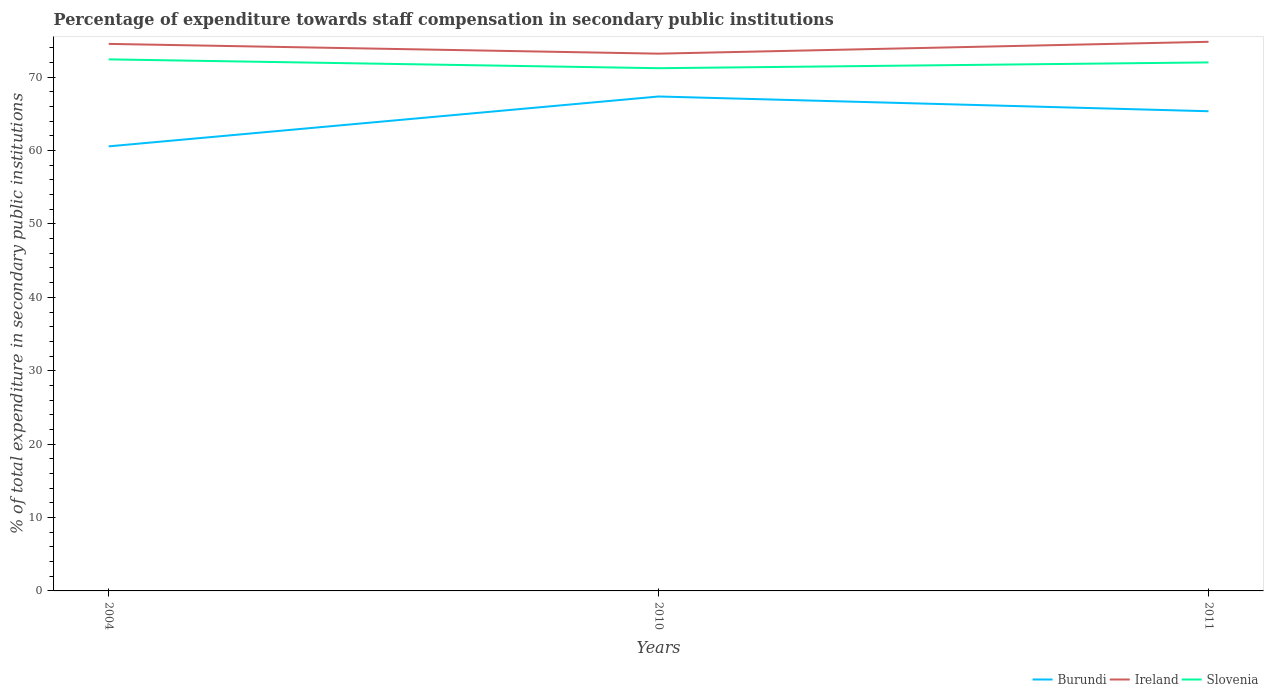Across all years, what is the maximum percentage of expenditure towards staff compensation in Burundi?
Ensure brevity in your answer.  60.57. In which year was the percentage of expenditure towards staff compensation in Burundi maximum?
Make the answer very short. 2004. What is the total percentage of expenditure towards staff compensation in Ireland in the graph?
Offer a terse response. -0.29. What is the difference between the highest and the second highest percentage of expenditure towards staff compensation in Slovenia?
Give a very brief answer. 1.2. How many lines are there?
Offer a very short reply. 3. How many years are there in the graph?
Offer a very short reply. 3. What is the difference between two consecutive major ticks on the Y-axis?
Give a very brief answer. 10. Are the values on the major ticks of Y-axis written in scientific E-notation?
Keep it short and to the point. No. Does the graph contain any zero values?
Ensure brevity in your answer.  No. Does the graph contain grids?
Ensure brevity in your answer.  No. How many legend labels are there?
Your answer should be very brief. 3. What is the title of the graph?
Make the answer very short. Percentage of expenditure towards staff compensation in secondary public institutions. Does "High income: OECD" appear as one of the legend labels in the graph?
Your response must be concise. No. What is the label or title of the Y-axis?
Give a very brief answer. % of total expenditure in secondary public institutions. What is the % of total expenditure in secondary public institutions of Burundi in 2004?
Your answer should be compact. 60.57. What is the % of total expenditure in secondary public institutions of Ireland in 2004?
Offer a terse response. 74.53. What is the % of total expenditure in secondary public institutions in Slovenia in 2004?
Ensure brevity in your answer.  72.42. What is the % of total expenditure in secondary public institutions in Burundi in 2010?
Your answer should be compact. 67.37. What is the % of total expenditure in secondary public institutions in Ireland in 2010?
Make the answer very short. 73.2. What is the % of total expenditure in secondary public institutions in Slovenia in 2010?
Offer a terse response. 71.22. What is the % of total expenditure in secondary public institutions of Burundi in 2011?
Offer a very short reply. 65.36. What is the % of total expenditure in secondary public institutions of Ireland in 2011?
Your response must be concise. 74.82. What is the % of total expenditure in secondary public institutions of Slovenia in 2011?
Give a very brief answer. 72.01. Across all years, what is the maximum % of total expenditure in secondary public institutions of Burundi?
Your answer should be very brief. 67.37. Across all years, what is the maximum % of total expenditure in secondary public institutions of Ireland?
Ensure brevity in your answer.  74.82. Across all years, what is the maximum % of total expenditure in secondary public institutions in Slovenia?
Your answer should be compact. 72.42. Across all years, what is the minimum % of total expenditure in secondary public institutions of Burundi?
Make the answer very short. 60.57. Across all years, what is the minimum % of total expenditure in secondary public institutions of Ireland?
Offer a very short reply. 73.2. Across all years, what is the minimum % of total expenditure in secondary public institutions in Slovenia?
Give a very brief answer. 71.22. What is the total % of total expenditure in secondary public institutions of Burundi in the graph?
Ensure brevity in your answer.  193.3. What is the total % of total expenditure in secondary public institutions of Ireland in the graph?
Provide a succinct answer. 222.55. What is the total % of total expenditure in secondary public institutions of Slovenia in the graph?
Your answer should be compact. 215.65. What is the difference between the % of total expenditure in secondary public institutions of Burundi in 2004 and that in 2010?
Make the answer very short. -6.79. What is the difference between the % of total expenditure in secondary public institutions in Ireland in 2004 and that in 2010?
Give a very brief answer. 1.33. What is the difference between the % of total expenditure in secondary public institutions in Slovenia in 2004 and that in 2010?
Your response must be concise. 1.2. What is the difference between the % of total expenditure in secondary public institutions of Burundi in 2004 and that in 2011?
Your response must be concise. -4.78. What is the difference between the % of total expenditure in secondary public institutions in Ireland in 2004 and that in 2011?
Keep it short and to the point. -0.29. What is the difference between the % of total expenditure in secondary public institutions in Slovenia in 2004 and that in 2011?
Keep it short and to the point. 0.42. What is the difference between the % of total expenditure in secondary public institutions in Burundi in 2010 and that in 2011?
Make the answer very short. 2.01. What is the difference between the % of total expenditure in secondary public institutions of Ireland in 2010 and that in 2011?
Keep it short and to the point. -1.62. What is the difference between the % of total expenditure in secondary public institutions in Slovenia in 2010 and that in 2011?
Provide a short and direct response. -0.79. What is the difference between the % of total expenditure in secondary public institutions in Burundi in 2004 and the % of total expenditure in secondary public institutions in Ireland in 2010?
Offer a very short reply. -12.63. What is the difference between the % of total expenditure in secondary public institutions of Burundi in 2004 and the % of total expenditure in secondary public institutions of Slovenia in 2010?
Make the answer very short. -10.65. What is the difference between the % of total expenditure in secondary public institutions in Ireland in 2004 and the % of total expenditure in secondary public institutions in Slovenia in 2010?
Provide a succinct answer. 3.31. What is the difference between the % of total expenditure in secondary public institutions in Burundi in 2004 and the % of total expenditure in secondary public institutions in Ireland in 2011?
Offer a terse response. -14.24. What is the difference between the % of total expenditure in secondary public institutions in Burundi in 2004 and the % of total expenditure in secondary public institutions in Slovenia in 2011?
Offer a very short reply. -11.44. What is the difference between the % of total expenditure in secondary public institutions of Ireland in 2004 and the % of total expenditure in secondary public institutions of Slovenia in 2011?
Your answer should be very brief. 2.52. What is the difference between the % of total expenditure in secondary public institutions in Burundi in 2010 and the % of total expenditure in secondary public institutions in Ireland in 2011?
Your answer should be compact. -7.45. What is the difference between the % of total expenditure in secondary public institutions of Burundi in 2010 and the % of total expenditure in secondary public institutions of Slovenia in 2011?
Offer a very short reply. -4.64. What is the difference between the % of total expenditure in secondary public institutions in Ireland in 2010 and the % of total expenditure in secondary public institutions in Slovenia in 2011?
Provide a short and direct response. 1.19. What is the average % of total expenditure in secondary public institutions in Burundi per year?
Provide a short and direct response. 64.43. What is the average % of total expenditure in secondary public institutions of Ireland per year?
Give a very brief answer. 74.18. What is the average % of total expenditure in secondary public institutions in Slovenia per year?
Offer a very short reply. 71.88. In the year 2004, what is the difference between the % of total expenditure in secondary public institutions in Burundi and % of total expenditure in secondary public institutions in Ireland?
Offer a terse response. -13.96. In the year 2004, what is the difference between the % of total expenditure in secondary public institutions in Burundi and % of total expenditure in secondary public institutions in Slovenia?
Provide a succinct answer. -11.85. In the year 2004, what is the difference between the % of total expenditure in secondary public institutions of Ireland and % of total expenditure in secondary public institutions of Slovenia?
Give a very brief answer. 2.11. In the year 2010, what is the difference between the % of total expenditure in secondary public institutions of Burundi and % of total expenditure in secondary public institutions of Ireland?
Your answer should be compact. -5.84. In the year 2010, what is the difference between the % of total expenditure in secondary public institutions of Burundi and % of total expenditure in secondary public institutions of Slovenia?
Give a very brief answer. -3.85. In the year 2010, what is the difference between the % of total expenditure in secondary public institutions in Ireland and % of total expenditure in secondary public institutions in Slovenia?
Your answer should be very brief. 1.98. In the year 2011, what is the difference between the % of total expenditure in secondary public institutions in Burundi and % of total expenditure in secondary public institutions in Ireland?
Your answer should be compact. -9.46. In the year 2011, what is the difference between the % of total expenditure in secondary public institutions of Burundi and % of total expenditure in secondary public institutions of Slovenia?
Offer a very short reply. -6.65. In the year 2011, what is the difference between the % of total expenditure in secondary public institutions of Ireland and % of total expenditure in secondary public institutions of Slovenia?
Provide a short and direct response. 2.81. What is the ratio of the % of total expenditure in secondary public institutions in Burundi in 2004 to that in 2010?
Provide a short and direct response. 0.9. What is the ratio of the % of total expenditure in secondary public institutions in Ireland in 2004 to that in 2010?
Ensure brevity in your answer.  1.02. What is the ratio of the % of total expenditure in secondary public institutions of Slovenia in 2004 to that in 2010?
Keep it short and to the point. 1.02. What is the ratio of the % of total expenditure in secondary public institutions in Burundi in 2004 to that in 2011?
Make the answer very short. 0.93. What is the ratio of the % of total expenditure in secondary public institutions of Ireland in 2004 to that in 2011?
Make the answer very short. 1. What is the ratio of the % of total expenditure in secondary public institutions of Burundi in 2010 to that in 2011?
Give a very brief answer. 1.03. What is the ratio of the % of total expenditure in secondary public institutions of Ireland in 2010 to that in 2011?
Keep it short and to the point. 0.98. What is the difference between the highest and the second highest % of total expenditure in secondary public institutions of Burundi?
Provide a succinct answer. 2.01. What is the difference between the highest and the second highest % of total expenditure in secondary public institutions in Ireland?
Offer a terse response. 0.29. What is the difference between the highest and the second highest % of total expenditure in secondary public institutions of Slovenia?
Keep it short and to the point. 0.42. What is the difference between the highest and the lowest % of total expenditure in secondary public institutions of Burundi?
Your answer should be compact. 6.79. What is the difference between the highest and the lowest % of total expenditure in secondary public institutions of Ireland?
Provide a succinct answer. 1.62. What is the difference between the highest and the lowest % of total expenditure in secondary public institutions of Slovenia?
Provide a succinct answer. 1.2. 